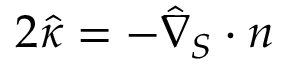<formula> <loc_0><loc_0><loc_500><loc_500>2 \hat { \kappa } = - \hat { \nabla } _ { S } \cdot n</formula> 